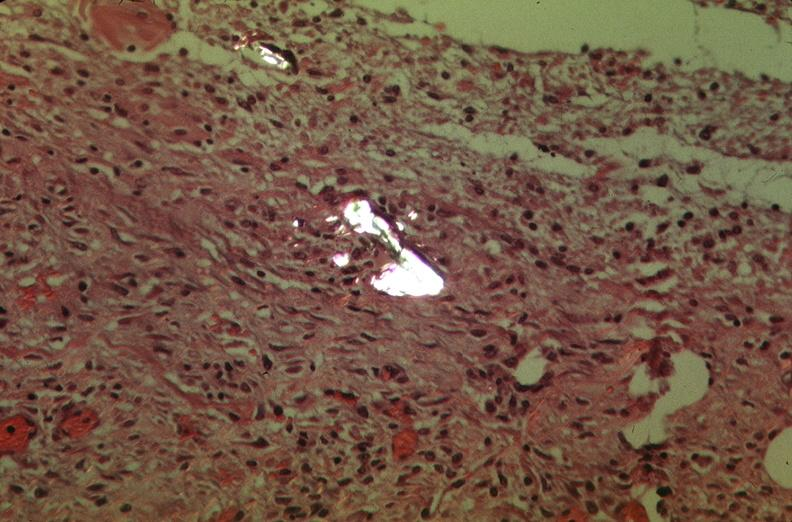s angiogram present?
Answer the question using a single word or phrase. No 